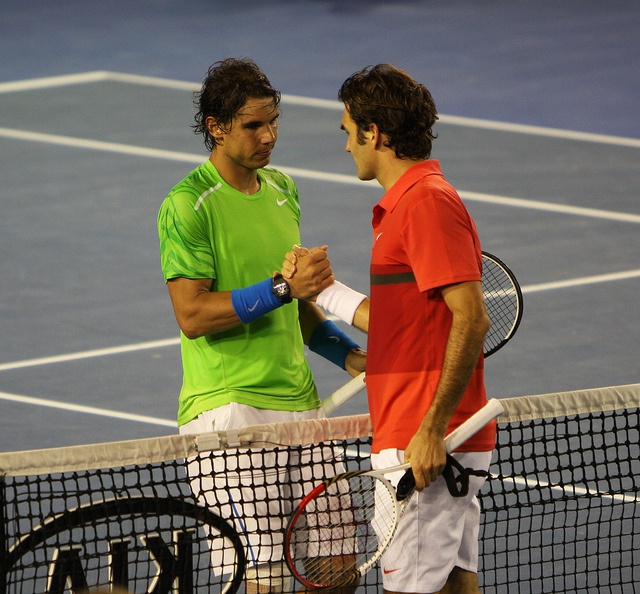Describe the objects in this image and their specific colors. I can see people in blue, olive, black, brown, and maroon tones, people in blue, brown, black, red, and maroon tones, tennis racket in blue, black, gray, maroon, and tan tones, and tennis racket in blue, gray, black, tan, and darkgray tones in this image. 